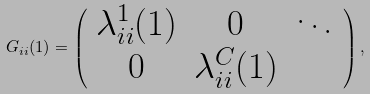Convert formula to latex. <formula><loc_0><loc_0><loc_500><loc_500>G _ { i i } ( 1 ) = \left ( \begin{array} { c c c } \lambda _ { i i } ^ { 1 } ( 1 ) & { 0 } & \ddots \\ { 0 } & \lambda _ { i i } ^ { C } ( 1 ) \end{array} \right ) ,</formula> 